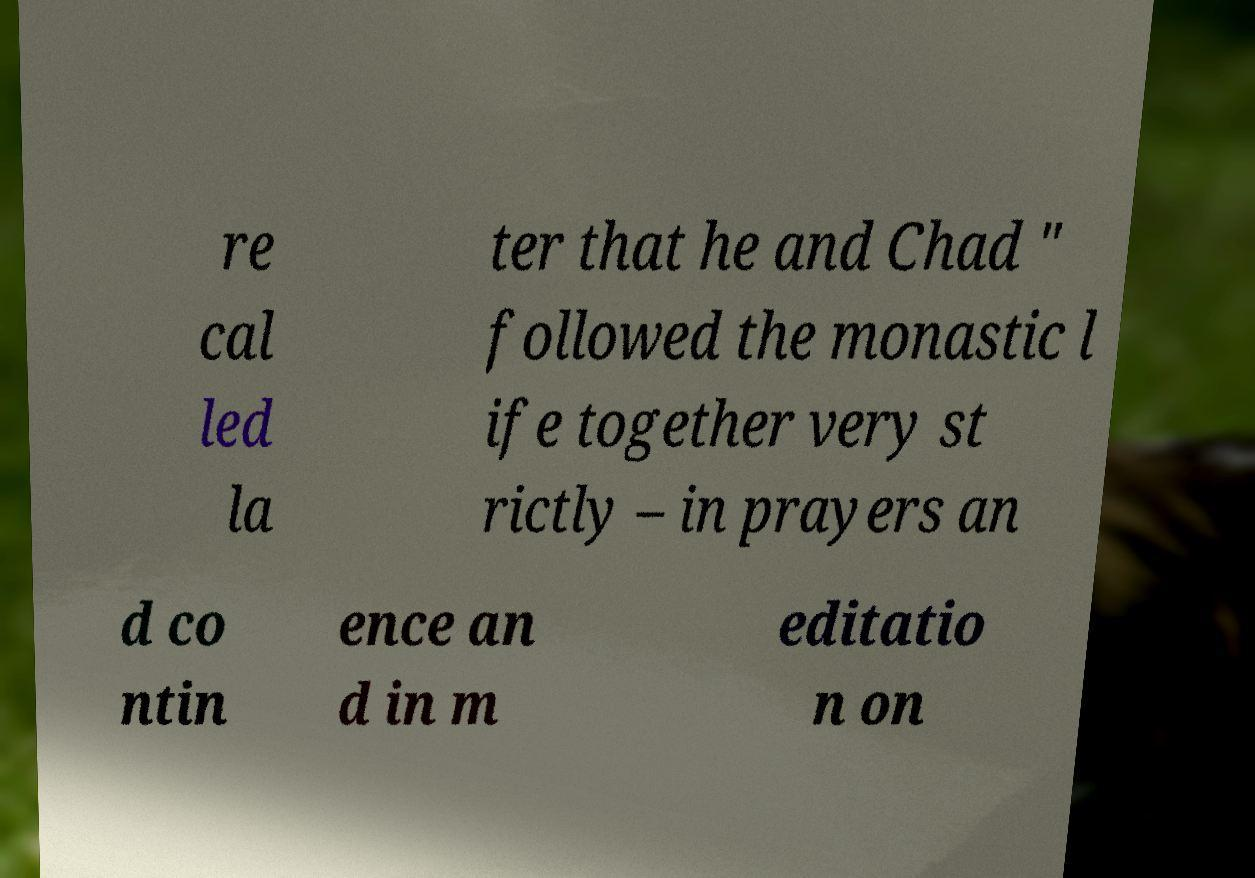What messages or text are displayed in this image? I need them in a readable, typed format. re cal led la ter that he and Chad " followed the monastic l ife together very st rictly – in prayers an d co ntin ence an d in m editatio n on 